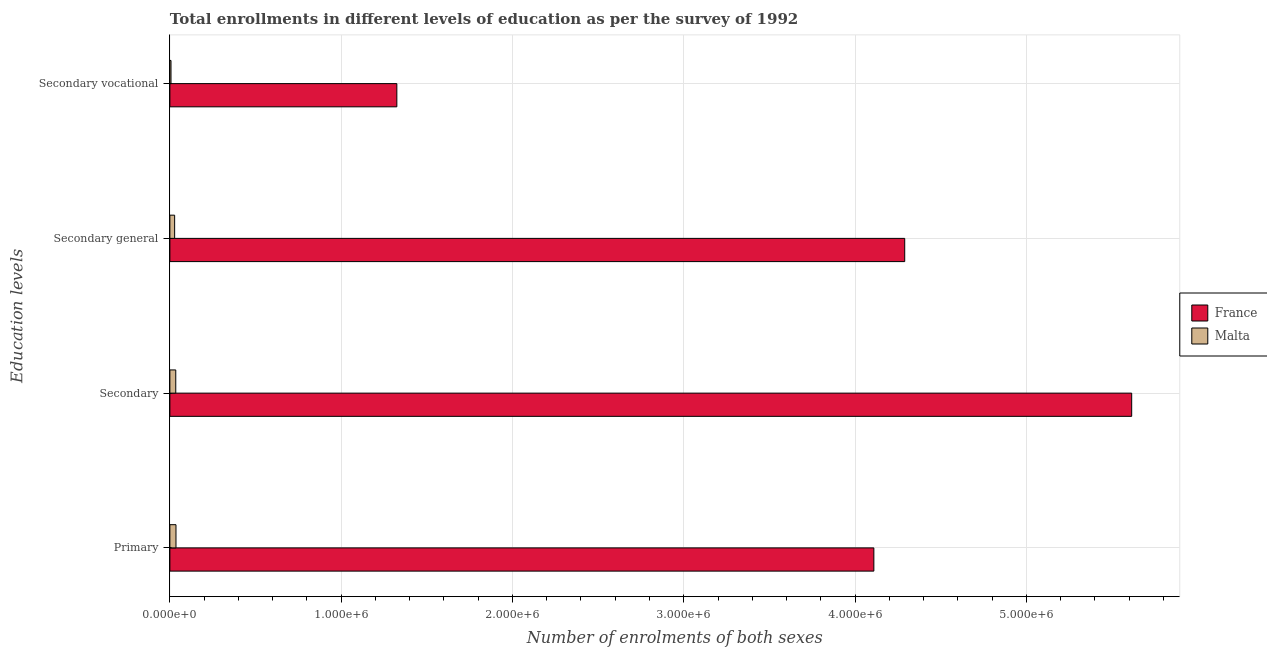How many different coloured bars are there?
Keep it short and to the point. 2. How many groups of bars are there?
Ensure brevity in your answer.  4. Are the number of bars per tick equal to the number of legend labels?
Provide a succinct answer. Yes. How many bars are there on the 3rd tick from the bottom?
Provide a short and direct response. 2. What is the label of the 2nd group of bars from the top?
Ensure brevity in your answer.  Secondary general. What is the number of enrolments in secondary education in France?
Offer a very short reply. 5.61e+06. Across all countries, what is the maximum number of enrolments in secondary education?
Your answer should be compact. 5.61e+06. Across all countries, what is the minimum number of enrolments in primary education?
Your answer should be very brief. 3.56e+04. In which country was the number of enrolments in secondary general education minimum?
Give a very brief answer. Malta. What is the total number of enrolments in secondary education in the graph?
Give a very brief answer. 5.65e+06. What is the difference between the number of enrolments in secondary education in Malta and that in France?
Your answer should be compact. -5.58e+06. What is the difference between the number of enrolments in secondary general education in Malta and the number of enrolments in secondary vocational education in France?
Make the answer very short. -1.30e+06. What is the average number of enrolments in secondary general education per country?
Your answer should be very brief. 2.16e+06. What is the difference between the number of enrolments in primary education and number of enrolments in secondary general education in Malta?
Offer a very short reply. 7829. In how many countries, is the number of enrolments in secondary vocational education greater than 2600000 ?
Ensure brevity in your answer.  0. What is the ratio of the number of enrolments in secondary education in France to that in Malta?
Ensure brevity in your answer.  163.42. Is the difference between the number of enrolments in secondary vocational education in France and Malta greater than the difference between the number of enrolments in secondary education in France and Malta?
Make the answer very short. No. What is the difference between the highest and the second highest number of enrolments in secondary education?
Provide a succinct answer. 5.58e+06. What is the difference between the highest and the lowest number of enrolments in secondary general education?
Offer a very short reply. 4.26e+06. In how many countries, is the number of enrolments in secondary general education greater than the average number of enrolments in secondary general education taken over all countries?
Keep it short and to the point. 1. Is it the case that in every country, the sum of the number of enrolments in secondary vocational education and number of enrolments in secondary education is greater than the sum of number of enrolments in primary education and number of enrolments in secondary general education?
Provide a succinct answer. No. What does the 1st bar from the top in Secondary vocational represents?
Give a very brief answer. Malta. Is it the case that in every country, the sum of the number of enrolments in primary education and number of enrolments in secondary education is greater than the number of enrolments in secondary general education?
Make the answer very short. Yes. How many countries are there in the graph?
Give a very brief answer. 2. What is the difference between two consecutive major ticks on the X-axis?
Your answer should be compact. 1.00e+06. Are the values on the major ticks of X-axis written in scientific E-notation?
Your response must be concise. Yes. Does the graph contain any zero values?
Your answer should be very brief. No. Does the graph contain grids?
Your answer should be compact. Yes. Where does the legend appear in the graph?
Your answer should be very brief. Center right. What is the title of the graph?
Give a very brief answer. Total enrollments in different levels of education as per the survey of 1992. Does "Namibia" appear as one of the legend labels in the graph?
Your answer should be very brief. No. What is the label or title of the X-axis?
Your answer should be compact. Number of enrolments of both sexes. What is the label or title of the Y-axis?
Offer a terse response. Education levels. What is the Number of enrolments of both sexes in France in Primary?
Your answer should be compact. 4.11e+06. What is the Number of enrolments of both sexes of Malta in Primary?
Your answer should be very brief. 3.56e+04. What is the Number of enrolments of both sexes in France in Secondary?
Your response must be concise. 5.61e+06. What is the Number of enrolments of both sexes of Malta in Secondary?
Your response must be concise. 3.44e+04. What is the Number of enrolments of both sexes of France in Secondary general?
Provide a short and direct response. 4.29e+06. What is the Number of enrolments of both sexes of Malta in Secondary general?
Provide a succinct answer. 2.78e+04. What is the Number of enrolments of both sexes in France in Secondary vocational?
Give a very brief answer. 1.33e+06. What is the Number of enrolments of both sexes of Malta in Secondary vocational?
Keep it short and to the point. 6561. Across all Education levels, what is the maximum Number of enrolments of both sexes of France?
Your response must be concise. 5.61e+06. Across all Education levels, what is the maximum Number of enrolments of both sexes in Malta?
Your response must be concise. 3.56e+04. Across all Education levels, what is the minimum Number of enrolments of both sexes in France?
Ensure brevity in your answer.  1.33e+06. Across all Education levels, what is the minimum Number of enrolments of both sexes of Malta?
Offer a very short reply. 6561. What is the total Number of enrolments of both sexes in France in the graph?
Provide a succinct answer. 1.53e+07. What is the total Number of enrolments of both sexes of Malta in the graph?
Make the answer very short. 1.04e+05. What is the difference between the Number of enrolments of both sexes of France in Primary and that in Secondary?
Offer a terse response. -1.51e+06. What is the difference between the Number of enrolments of both sexes in Malta in Primary and that in Secondary?
Provide a succinct answer. 1268. What is the difference between the Number of enrolments of both sexes of France in Primary and that in Secondary general?
Make the answer very short. -1.80e+05. What is the difference between the Number of enrolments of both sexes of Malta in Primary and that in Secondary general?
Provide a short and direct response. 7829. What is the difference between the Number of enrolments of both sexes of France in Primary and that in Secondary vocational?
Provide a short and direct response. 2.78e+06. What is the difference between the Number of enrolments of both sexes of Malta in Primary and that in Secondary vocational?
Ensure brevity in your answer.  2.91e+04. What is the difference between the Number of enrolments of both sexes in France in Secondary and that in Secondary general?
Your answer should be compact. 1.33e+06. What is the difference between the Number of enrolments of both sexes in Malta in Secondary and that in Secondary general?
Give a very brief answer. 6561. What is the difference between the Number of enrolments of both sexes in France in Secondary and that in Secondary vocational?
Your response must be concise. 4.29e+06. What is the difference between the Number of enrolments of both sexes of Malta in Secondary and that in Secondary vocational?
Make the answer very short. 2.78e+04. What is the difference between the Number of enrolments of both sexes of France in Secondary general and that in Secondary vocational?
Your answer should be very brief. 2.96e+06. What is the difference between the Number of enrolments of both sexes in Malta in Secondary general and that in Secondary vocational?
Make the answer very short. 2.12e+04. What is the difference between the Number of enrolments of both sexes in France in Primary and the Number of enrolments of both sexes in Malta in Secondary?
Give a very brief answer. 4.08e+06. What is the difference between the Number of enrolments of both sexes in France in Primary and the Number of enrolments of both sexes in Malta in Secondary general?
Your answer should be compact. 4.08e+06. What is the difference between the Number of enrolments of both sexes in France in Primary and the Number of enrolments of both sexes in Malta in Secondary vocational?
Make the answer very short. 4.10e+06. What is the difference between the Number of enrolments of both sexes of France in Secondary and the Number of enrolments of both sexes of Malta in Secondary general?
Ensure brevity in your answer.  5.59e+06. What is the difference between the Number of enrolments of both sexes of France in Secondary and the Number of enrolments of both sexes of Malta in Secondary vocational?
Your response must be concise. 5.61e+06. What is the difference between the Number of enrolments of both sexes of France in Secondary general and the Number of enrolments of both sexes of Malta in Secondary vocational?
Offer a terse response. 4.28e+06. What is the average Number of enrolments of both sexes of France per Education levels?
Offer a very short reply. 3.83e+06. What is the average Number of enrolments of both sexes of Malta per Education levels?
Provide a short and direct response. 2.61e+04. What is the difference between the Number of enrolments of both sexes in France and Number of enrolments of both sexes in Malta in Primary?
Make the answer very short. 4.07e+06. What is the difference between the Number of enrolments of both sexes of France and Number of enrolments of both sexes of Malta in Secondary?
Offer a very short reply. 5.58e+06. What is the difference between the Number of enrolments of both sexes of France and Number of enrolments of both sexes of Malta in Secondary general?
Keep it short and to the point. 4.26e+06. What is the difference between the Number of enrolments of both sexes in France and Number of enrolments of both sexes in Malta in Secondary vocational?
Keep it short and to the point. 1.32e+06. What is the ratio of the Number of enrolments of both sexes of France in Primary to that in Secondary?
Your response must be concise. 0.73. What is the ratio of the Number of enrolments of both sexes of Malta in Primary to that in Secondary?
Your answer should be compact. 1.04. What is the ratio of the Number of enrolments of both sexes in France in Primary to that in Secondary general?
Provide a short and direct response. 0.96. What is the ratio of the Number of enrolments of both sexes in Malta in Primary to that in Secondary general?
Offer a terse response. 1.28. What is the ratio of the Number of enrolments of both sexes of France in Primary to that in Secondary vocational?
Make the answer very short. 3.1. What is the ratio of the Number of enrolments of both sexes in Malta in Primary to that in Secondary vocational?
Make the answer very short. 5.43. What is the ratio of the Number of enrolments of both sexes of France in Secondary to that in Secondary general?
Provide a short and direct response. 1.31. What is the ratio of the Number of enrolments of both sexes of Malta in Secondary to that in Secondary general?
Your response must be concise. 1.24. What is the ratio of the Number of enrolments of both sexes in France in Secondary to that in Secondary vocational?
Keep it short and to the point. 4.24. What is the ratio of the Number of enrolments of both sexes of Malta in Secondary to that in Secondary vocational?
Make the answer very short. 5.24. What is the ratio of the Number of enrolments of both sexes in France in Secondary general to that in Secondary vocational?
Provide a succinct answer. 3.24. What is the ratio of the Number of enrolments of both sexes of Malta in Secondary general to that in Secondary vocational?
Ensure brevity in your answer.  4.24. What is the difference between the highest and the second highest Number of enrolments of both sexes in France?
Provide a short and direct response. 1.33e+06. What is the difference between the highest and the second highest Number of enrolments of both sexes in Malta?
Your answer should be very brief. 1268. What is the difference between the highest and the lowest Number of enrolments of both sexes in France?
Offer a terse response. 4.29e+06. What is the difference between the highest and the lowest Number of enrolments of both sexes in Malta?
Your response must be concise. 2.91e+04. 